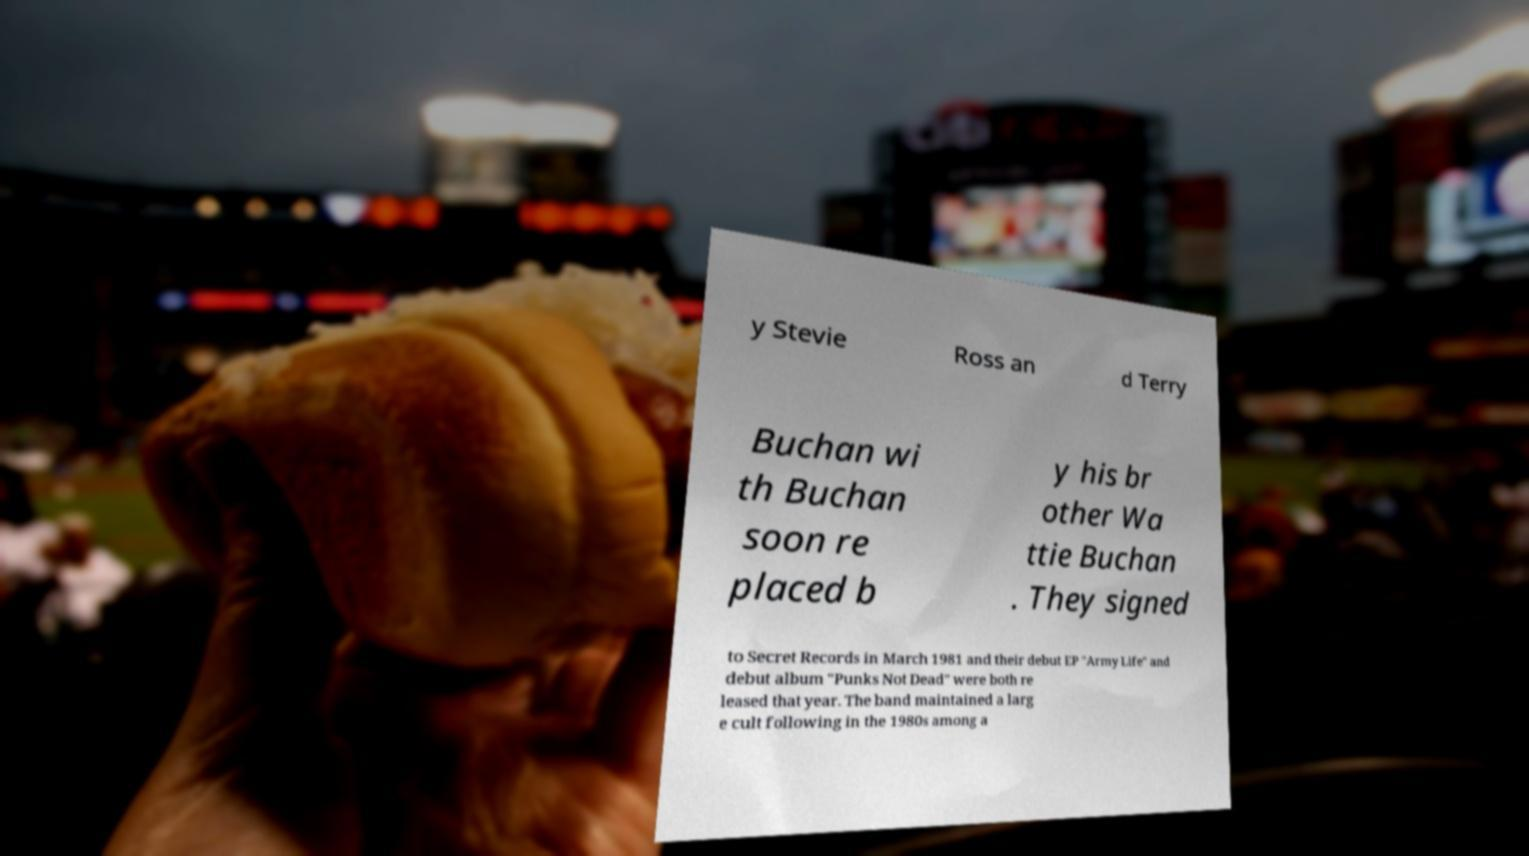Can you read and provide the text displayed in the image?This photo seems to have some interesting text. Can you extract and type it out for me? y Stevie Ross an d Terry Buchan wi th Buchan soon re placed b y his br other Wa ttie Buchan . They signed to Secret Records in March 1981 and their debut EP "Army Life" and debut album "Punks Not Dead" were both re leased that year. The band maintained a larg e cult following in the 1980s among a 